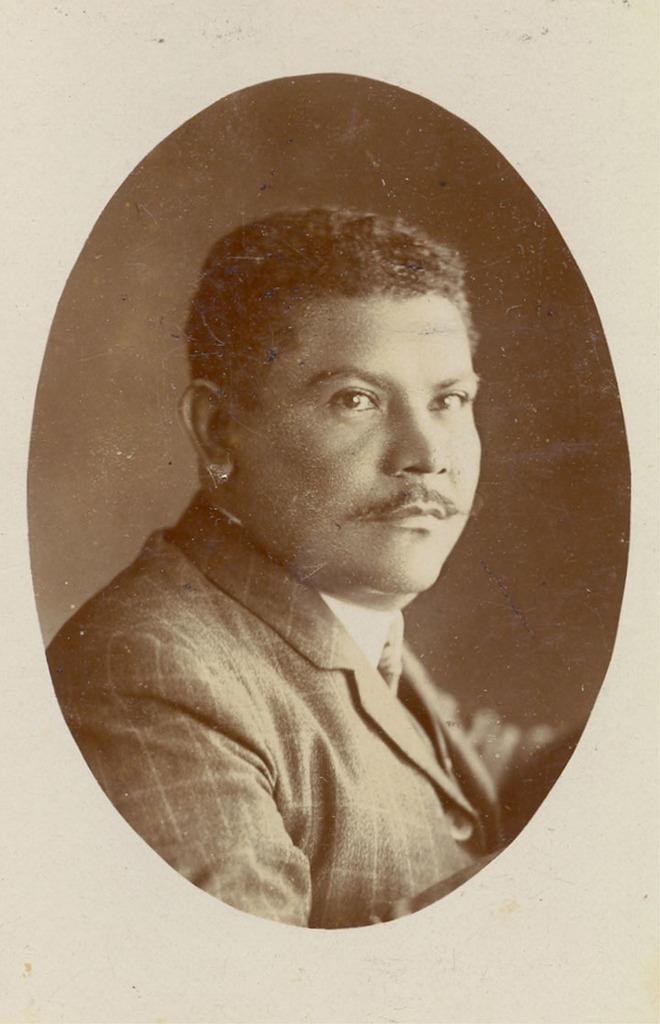Describe this image in one or two sentences. In this image in front there is a person. Behind him there is a wall. 